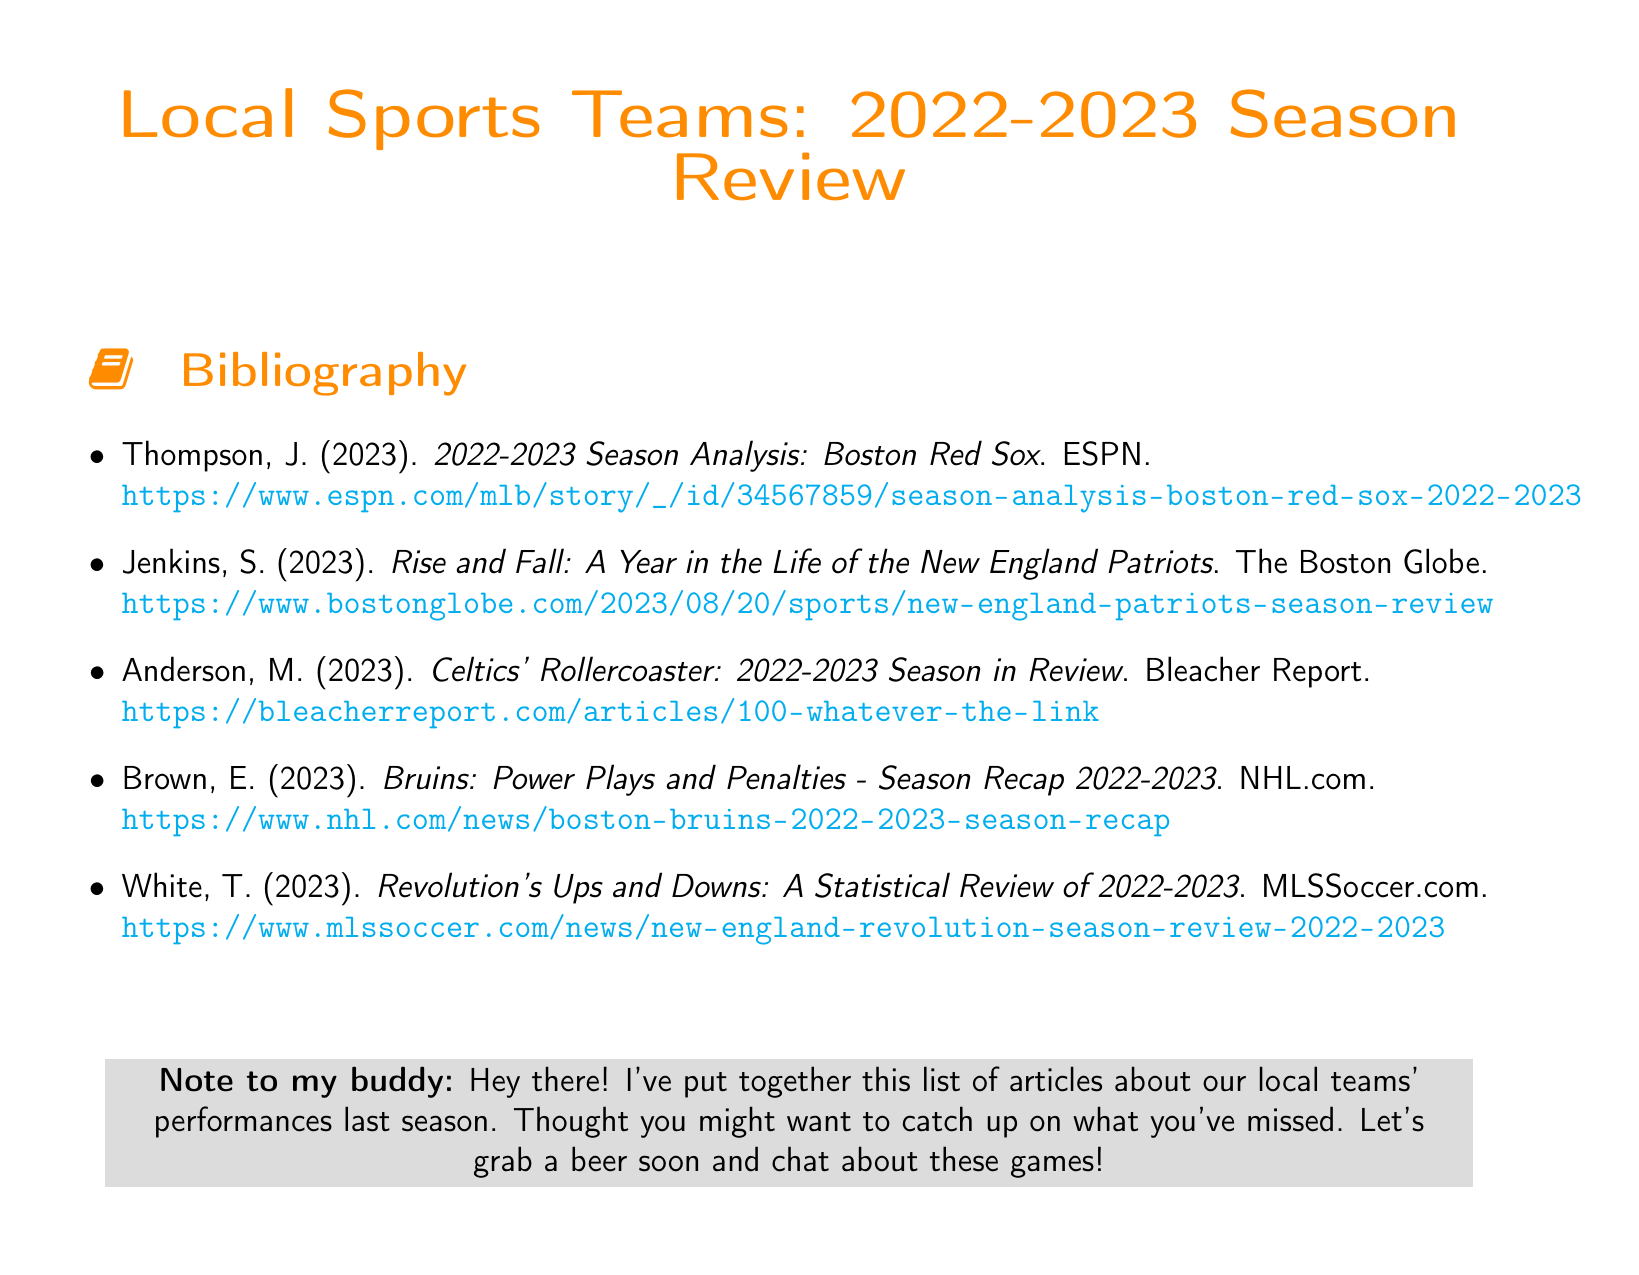What is the title of the document? The title is clearly stated at the beginning of the document.
Answer: Local Sports Teams: 2022-2023 Season Review Who authored the analysis of the Boston Red Sox? The author's name is listed in the bibliography entry for the Boston Red Sox.
Answer: Thompson, J What year do the articles in the bibliography review? The year is mentioned in the title of the seasons each article analyzes.
Answer: 2022-2023 How many articles are listed in the bibliography? The total number of items in the list provides this information directly.
Answer: 5 Which publication reviewed the New England Patriots' season? The publication is indicated in the citation related to the New England Patriots.
Answer: The Boston Globe What sports team is associated with the article authored by Brown, E.? The team's name is included in the title of Brown's article.
Answer: Bruins Which website published the article about the New England Revolution? The URL indicates the source of the article concerning the Revolution.
Answer: MLSSoccer.com What color is used for the section title in the document? The specific color used is mentioned in the document formatting.
Answer: sportsorange What is the primary mood conveyed in the note to the buddy? The overall sentiment is derived from the language used in the note.
Answer: Friendly 